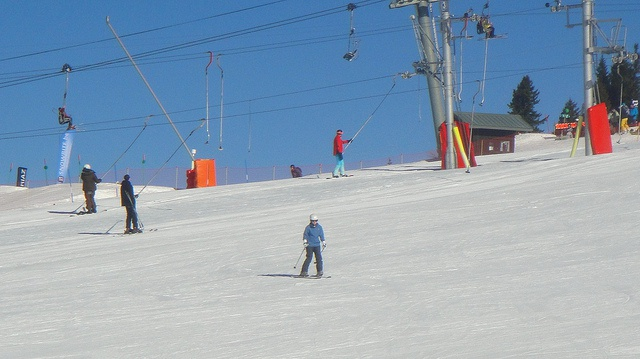Describe the objects in this image and their specific colors. I can see people in gray and darkgray tones, people in gray, lightgray, and black tones, people in gray, black, and darkblue tones, people in gray, lightblue, and darkgray tones, and people in gray, darkgray, black, and tan tones in this image. 